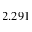Convert formula to latex. <formula><loc_0><loc_0><loc_500><loc_500>2 . 2 9 1</formula> 